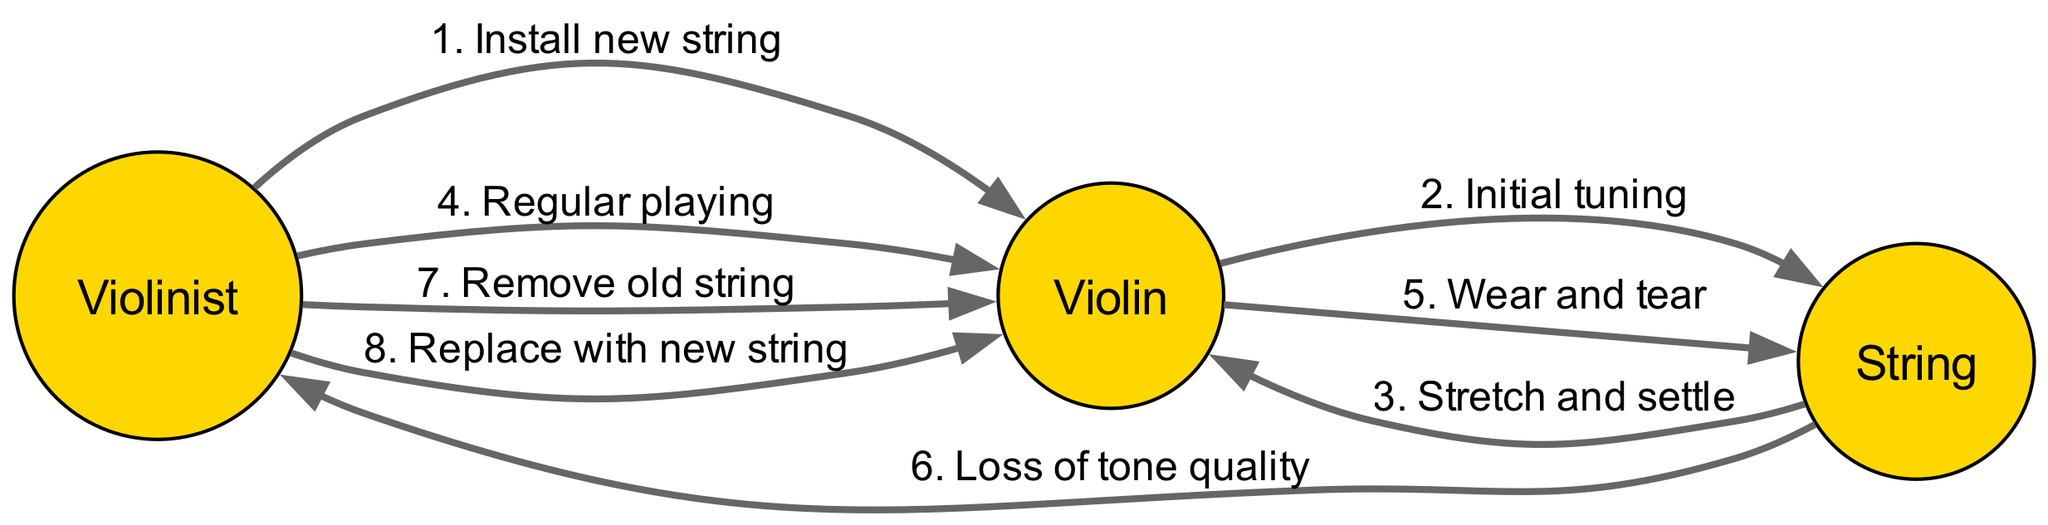What is the first action performed by the Violinist? The first action in the sequence diagram shows the Violinist installing a new string on the Violin. This is the first interaction in the lifecycle of the string.
Answer: Install new string How many total actions are represented in the sequence? By counting the actions listed in the sequence, there are a total of eight actions that occur from the installation to the replacement of the string.
Answer: 8 Who does the String communicate with to indicate wear and tear? The sequence indicates that the Violin communicates with the String during the wear and tear phase, showing the effect of regular playing on the String.
Answer: Violin What happens after the string stretches and settles? After the String has stretched and settled, the Violinist regularly plays the Violin, which continues to interact with the String throughout the lifecycle.
Answer: Regular playing What is the final action taken by the Violinist in the lifecycle of the string? The last action performed by the Violinist is replacing the old string with a new string, indicating the end of the lifecycle for that specific string.
Answer: Replace with new string Which action occurs immediately after regular playing? Following regular playing, the String experiences wear and tear, which is a direct consequence of the playing activity. This signifies the deterioration of the string's quality over time.
Answer: Wear and tear Which actor is involved in indicating loss of tone quality? The String is responsible for communicating the loss of tone quality to the Violinist, as indicated in the timeline where interaction flows from String to Violinist.
Answer: String How many actors are involved in the string lifecycle? The sequence diagram presents three distinct actors involved in the lifecycle of the violin string: the Violinist, the Violin, and the String.
Answer: 3 